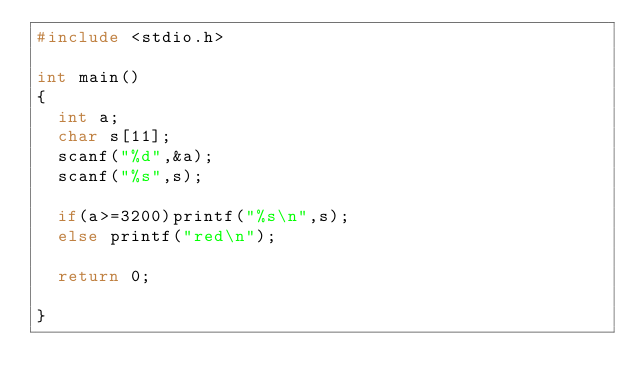Convert code to text. <code><loc_0><loc_0><loc_500><loc_500><_C_>#include <stdio.h>

int main()
{
  int a;
  char s[11];
  scanf("%d",&a);
  scanf("%s",s);

  if(a>=3200)printf("%s\n",s);
  else printf("red\n");

  return 0;
  
}</code> 